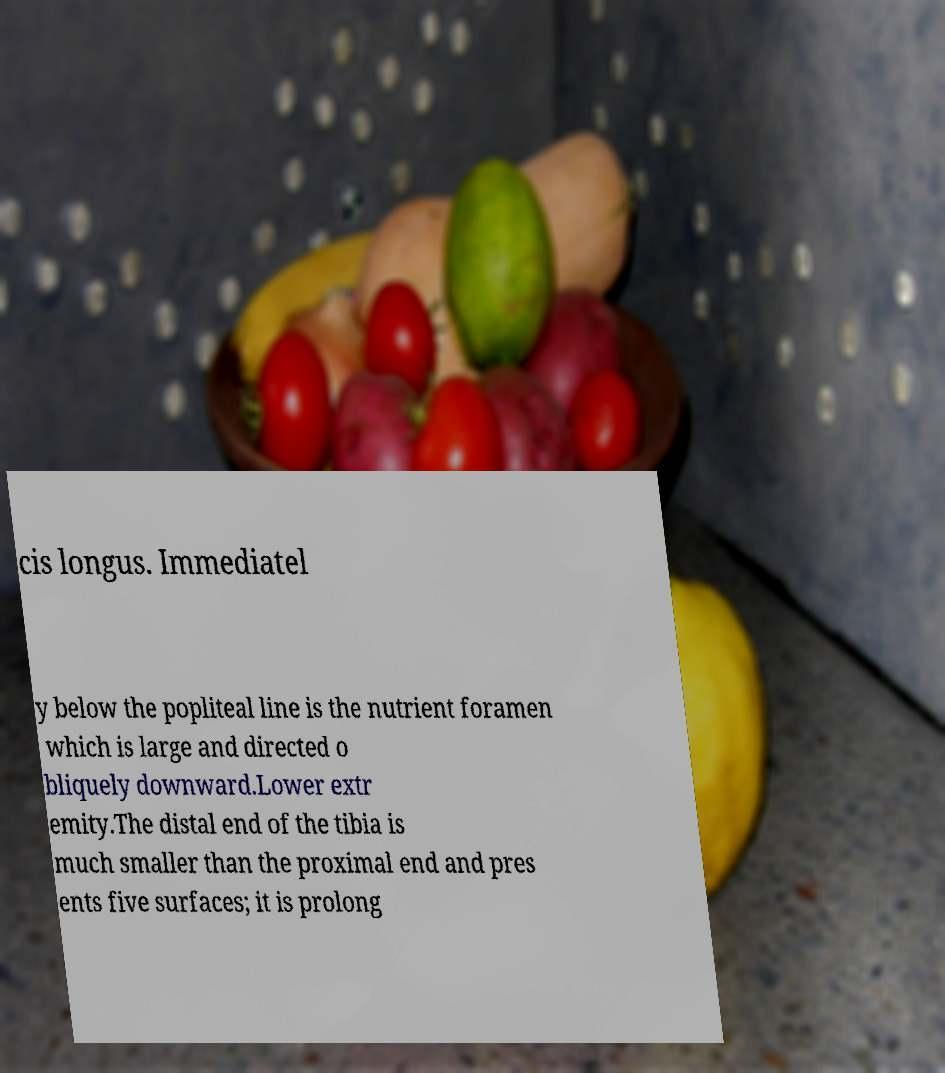Please read and relay the text visible in this image. What does it say? cis longus. Immediatel y below the popliteal line is the nutrient foramen which is large and directed o bliquely downward.Lower extr emity.The distal end of the tibia is much smaller than the proximal end and pres ents five surfaces; it is prolong 